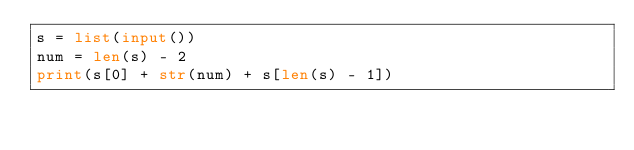<code> <loc_0><loc_0><loc_500><loc_500><_Python_>s = list(input())
num = len(s) - 2
print(s[0] + str(num) + s[len(s) - 1])</code> 